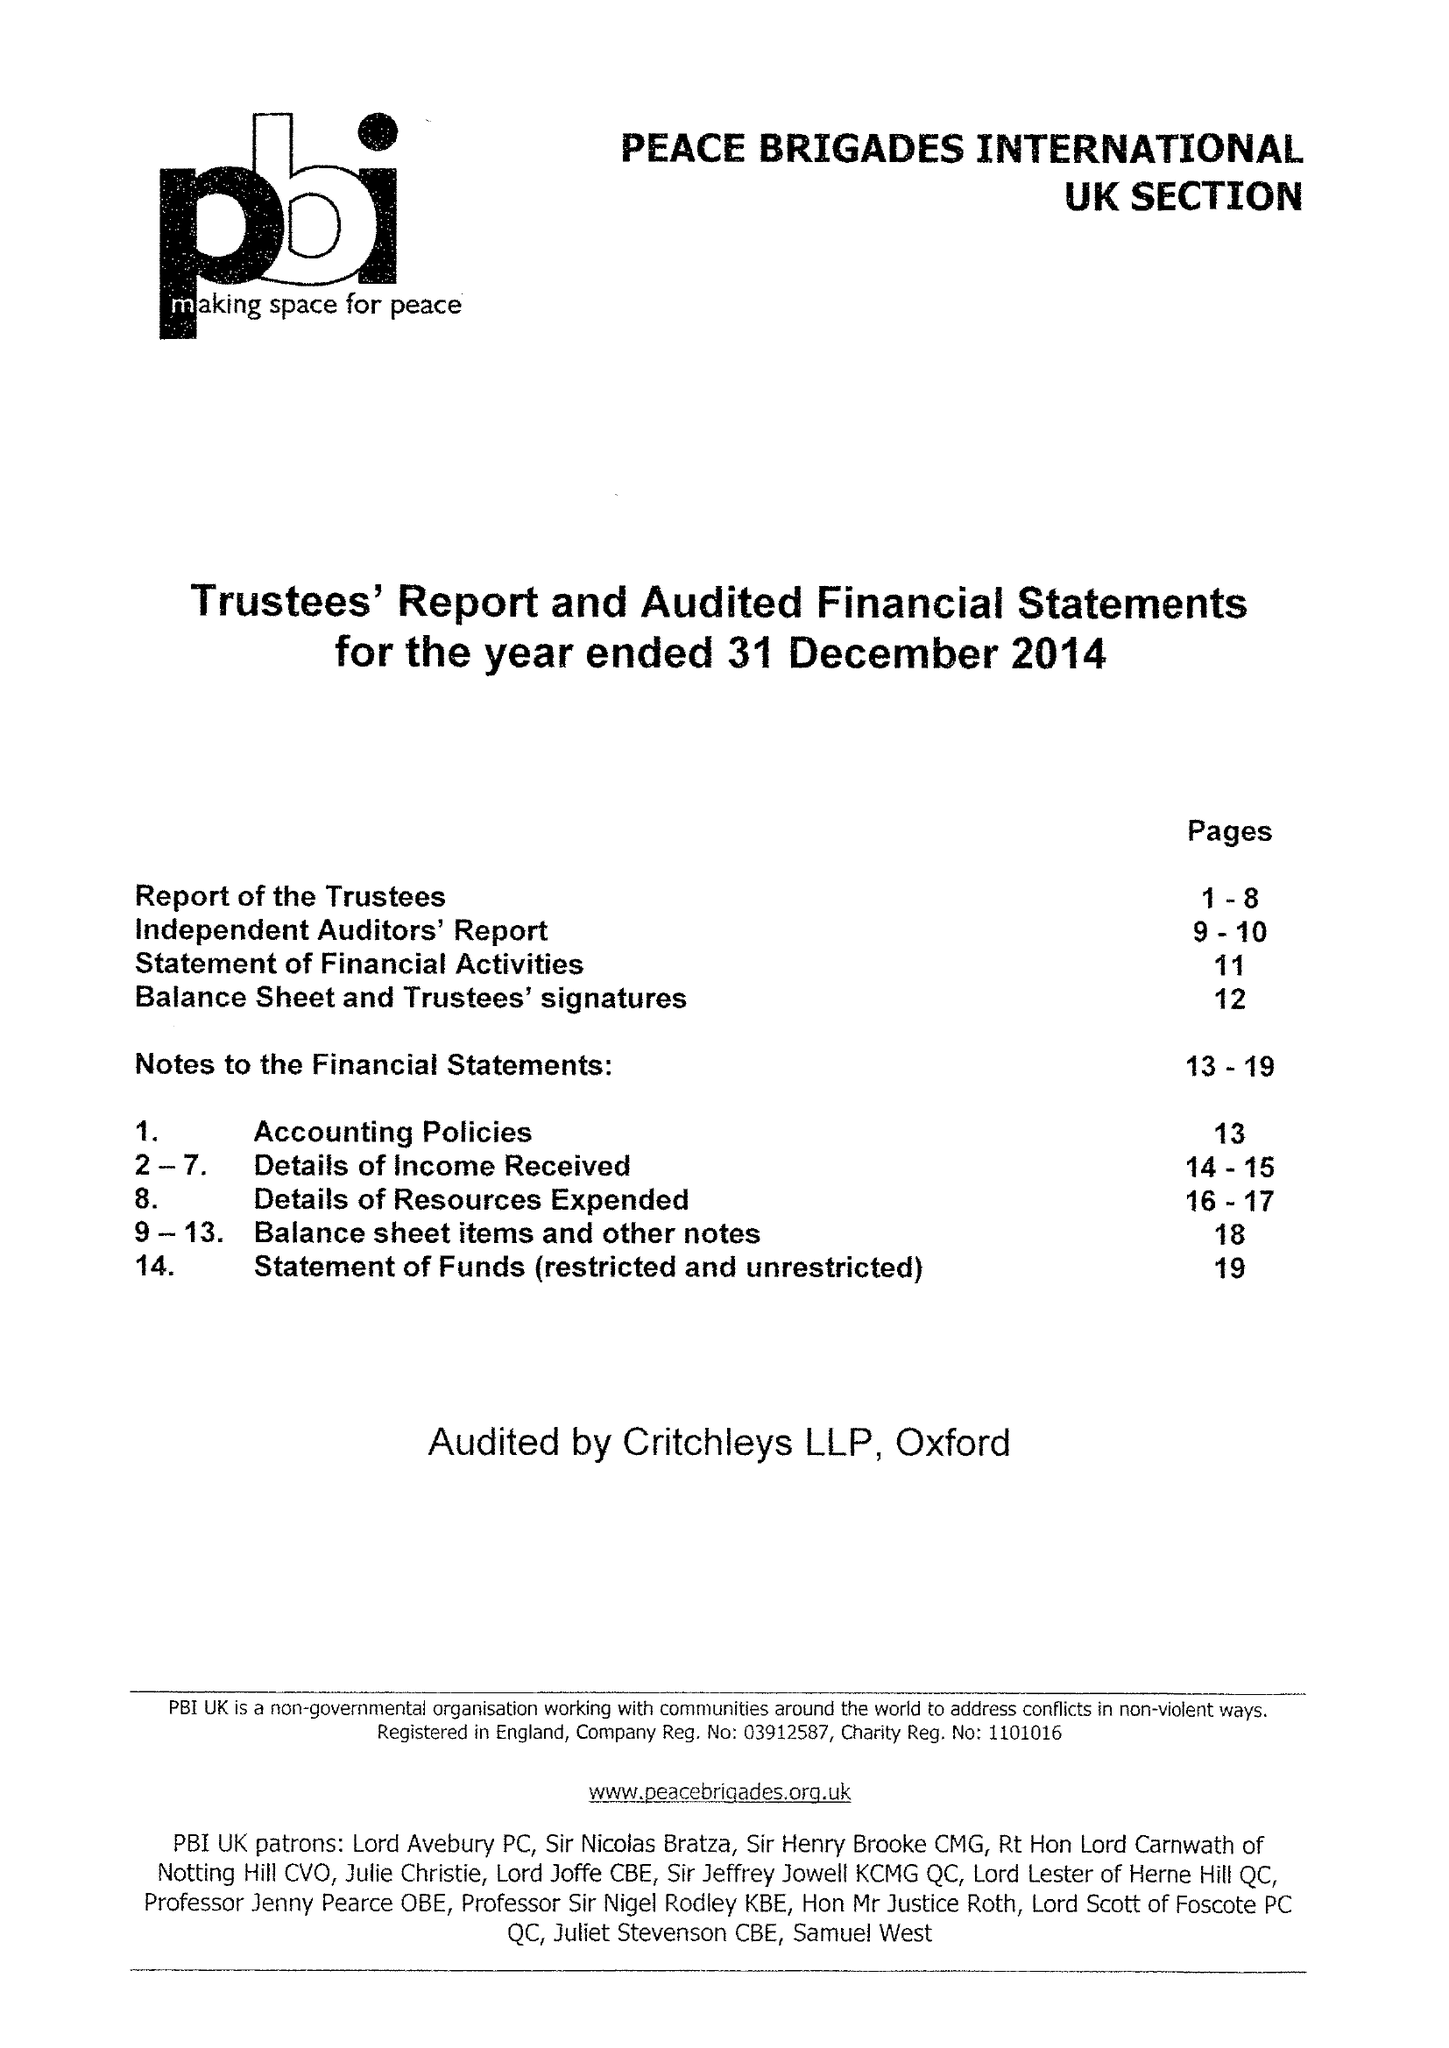What is the value for the charity_name?
Answer the question using a single word or phrase. Peace Brigades International Uk Section 